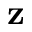<formula> <loc_0><loc_0><loc_500><loc_500>z</formula> 